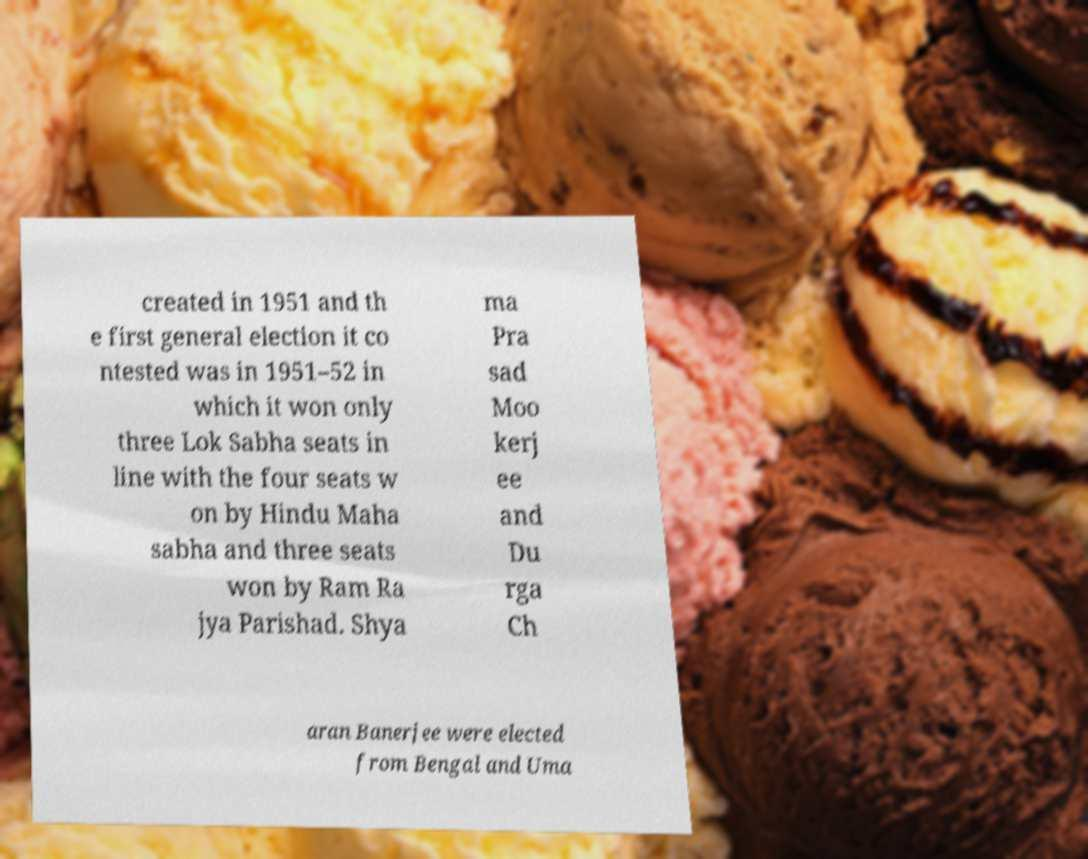For documentation purposes, I need the text within this image transcribed. Could you provide that? created in 1951 and th e first general election it co ntested was in 1951–52 in which it won only three Lok Sabha seats in line with the four seats w on by Hindu Maha sabha and three seats won by Ram Ra jya Parishad. Shya ma Pra sad Moo kerj ee and Du rga Ch aran Banerjee were elected from Bengal and Uma 